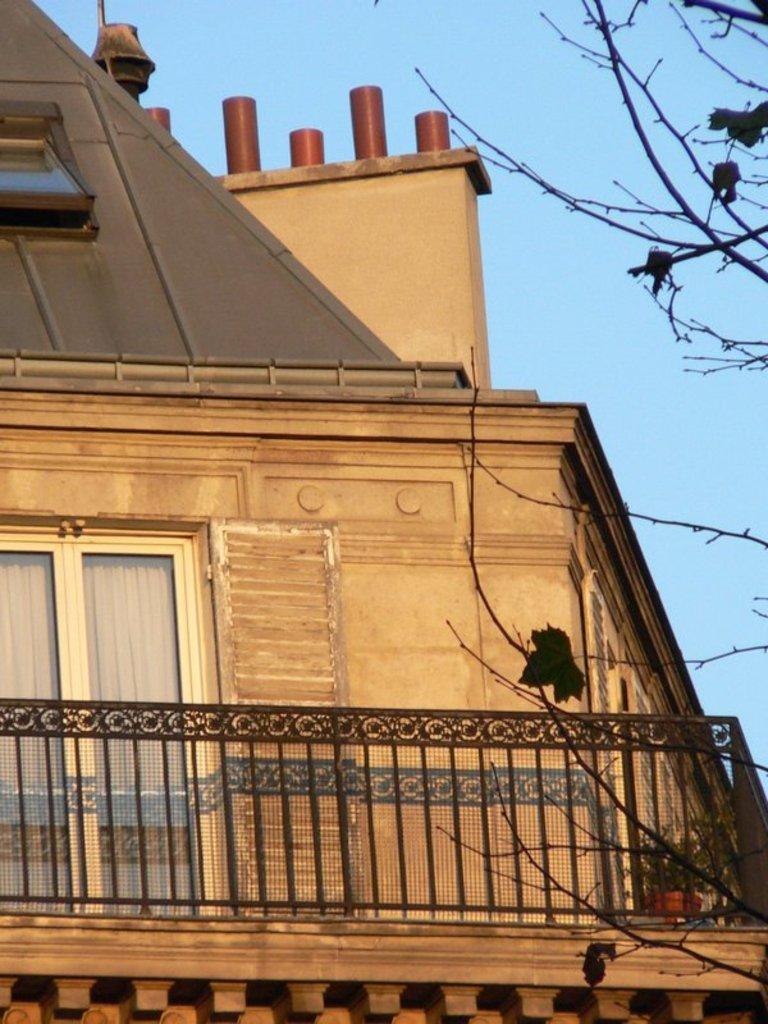Can you describe this image briefly? This image is taken outdoors. At the top of the image there is a sky. On the right side of the image there is a tree. In this image there is a building with walls, windows, a roof and a ventilator. There is a railing and there is a plant in the pot. 